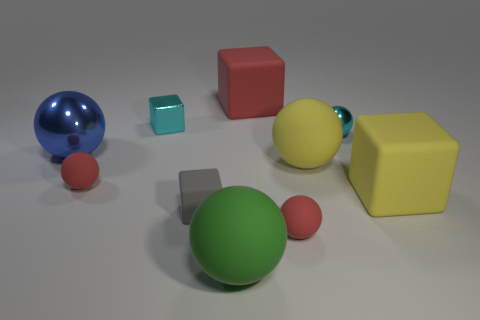The red thing that is the same size as the blue ball is what shape?
Ensure brevity in your answer.  Cube. Are there any yellow cubes right of the green matte sphere?
Your response must be concise. Yes. There is a small red thing behind the yellow block; is there a red object that is on the right side of it?
Keep it short and to the point. Yes. Is the number of large red objects that are in front of the large shiny sphere less than the number of cyan metallic objects that are behind the gray matte block?
Your answer should be compact. Yes. Is there any other thing that has the same size as the gray matte block?
Provide a short and direct response. Yes. What is the shape of the big blue thing?
Offer a very short reply. Sphere. There is a block in front of the big yellow block; what is it made of?
Ensure brevity in your answer.  Rubber. There is a shiny object that is on the right side of the large rubber ball that is in front of the big yellow rubber object to the left of the tiny cyan shiny ball; what size is it?
Your answer should be compact. Small. Is the material of the big block to the right of the tiny metal ball the same as the cube behind the shiny cube?
Your answer should be very brief. Yes. What number of other objects are the same color as the small shiny ball?
Ensure brevity in your answer.  1. 